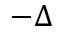<formula> <loc_0><loc_0><loc_500><loc_500>- \Delta</formula> 